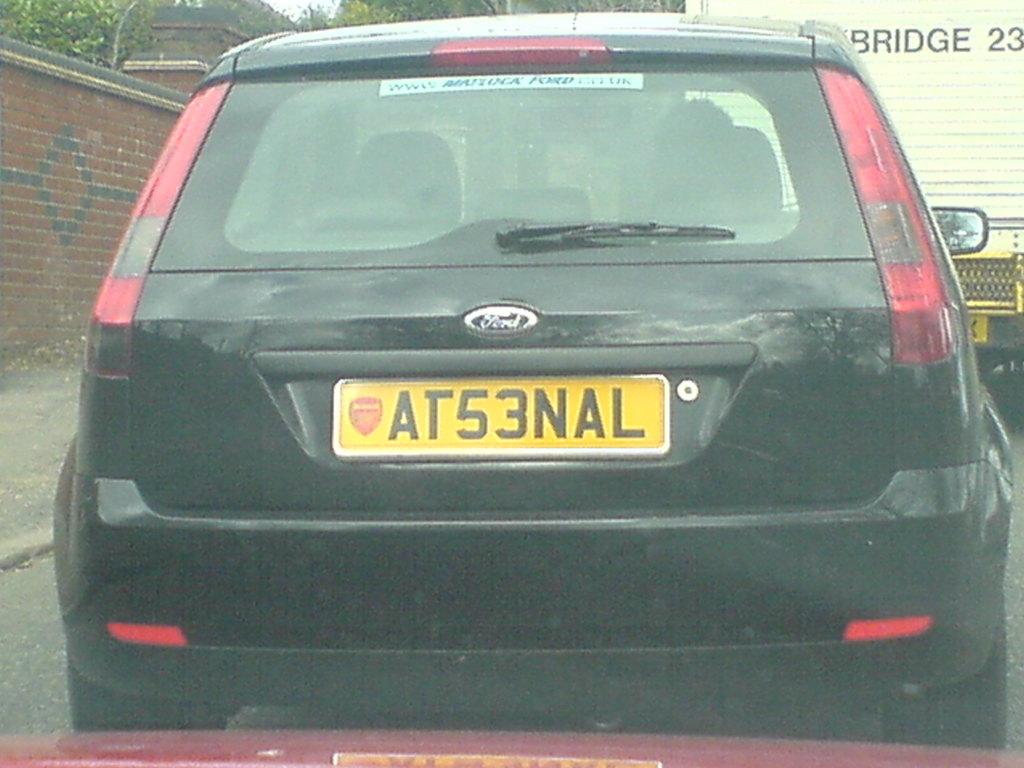What does the license plate read?
Your answer should be compact. At53nal. 